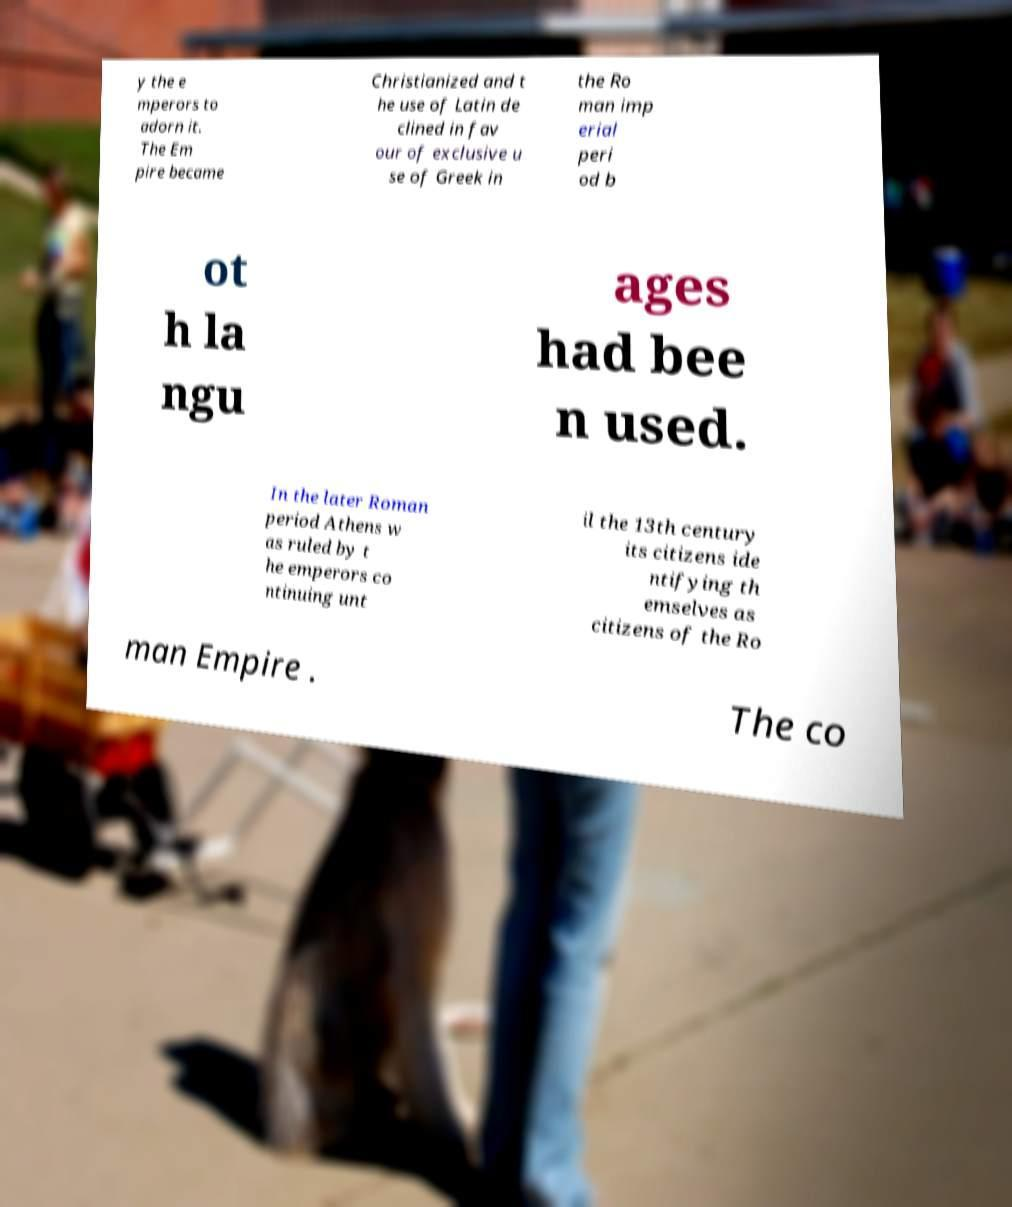Could you extract and type out the text from this image? y the e mperors to adorn it. The Em pire became Christianized and t he use of Latin de clined in fav our of exclusive u se of Greek in the Ro man imp erial peri od b ot h la ngu ages had bee n used. In the later Roman period Athens w as ruled by t he emperors co ntinuing unt il the 13th century its citizens ide ntifying th emselves as citizens of the Ro man Empire . The co 